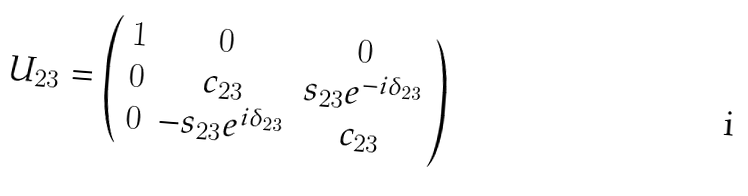<formula> <loc_0><loc_0><loc_500><loc_500>U _ { 2 3 } = \left ( \begin{array} { c c c } 1 & 0 & 0 \\ 0 & c _ { 2 3 } & s _ { 2 3 } e ^ { - i \delta _ { 2 3 } } \\ 0 & - s _ { 2 3 } e ^ { i \delta _ { 2 3 } } & c _ { 2 3 } \\ \end{array} \right )</formula> 